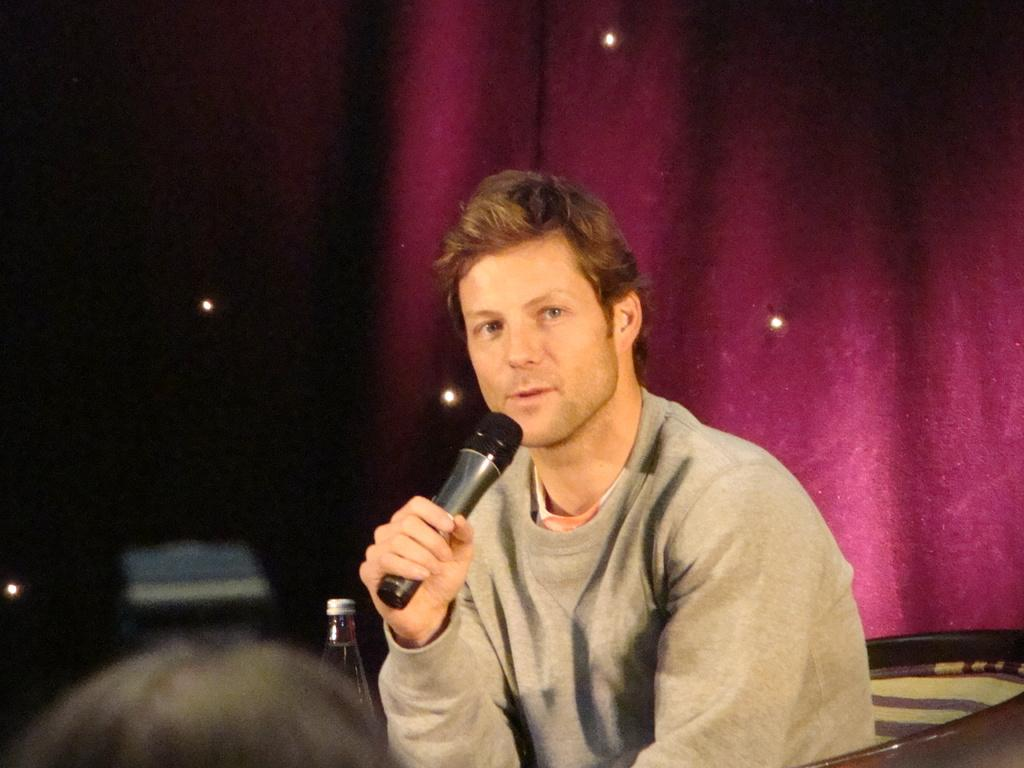What is the man in the image doing? The man is sitting and talking in the image. What is the man holding while talking? The man is holding a microphone. Can you describe the person in the foreground of the image? There is a person in the foreground of the image, but no specific details are provided. What can be seen in the background of the image? There is a bottle and a curtain in the background of the image. What time of day is it in the image, based on the presence of children playing on the edge? There are no children or any reference to a specific time of day in the image. 